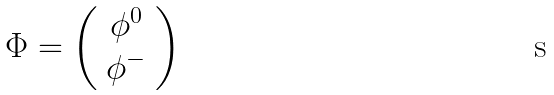Convert formula to latex. <formula><loc_0><loc_0><loc_500><loc_500>\Phi = \left ( \begin{array} { c } { { \phi ^ { 0 } } } \\ { { \phi ^ { - } } } \end{array} \right )</formula> 